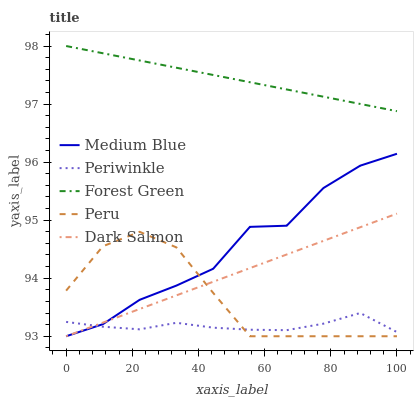Does Periwinkle have the minimum area under the curve?
Answer yes or no. Yes. Does Forest Green have the maximum area under the curve?
Answer yes or no. Yes. Does Medium Blue have the minimum area under the curve?
Answer yes or no. No. Does Medium Blue have the maximum area under the curve?
Answer yes or no. No. Is Dark Salmon the smoothest?
Answer yes or no. Yes. Is Medium Blue the roughest?
Answer yes or no. Yes. Is Forest Green the smoothest?
Answer yes or no. No. Is Forest Green the roughest?
Answer yes or no. No. Does Medium Blue have the lowest value?
Answer yes or no. Yes. Does Forest Green have the lowest value?
Answer yes or no. No. Does Forest Green have the highest value?
Answer yes or no. Yes. Does Medium Blue have the highest value?
Answer yes or no. No. Is Periwinkle less than Forest Green?
Answer yes or no. Yes. Is Forest Green greater than Medium Blue?
Answer yes or no. Yes. Does Medium Blue intersect Dark Salmon?
Answer yes or no. Yes. Is Medium Blue less than Dark Salmon?
Answer yes or no. No. Is Medium Blue greater than Dark Salmon?
Answer yes or no. No. Does Periwinkle intersect Forest Green?
Answer yes or no. No. 